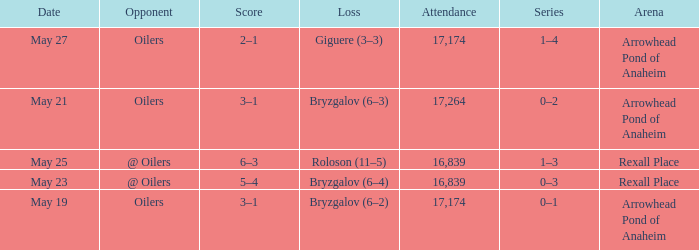How much attendance has a Loss of roloson (11–5)? 16839.0. 